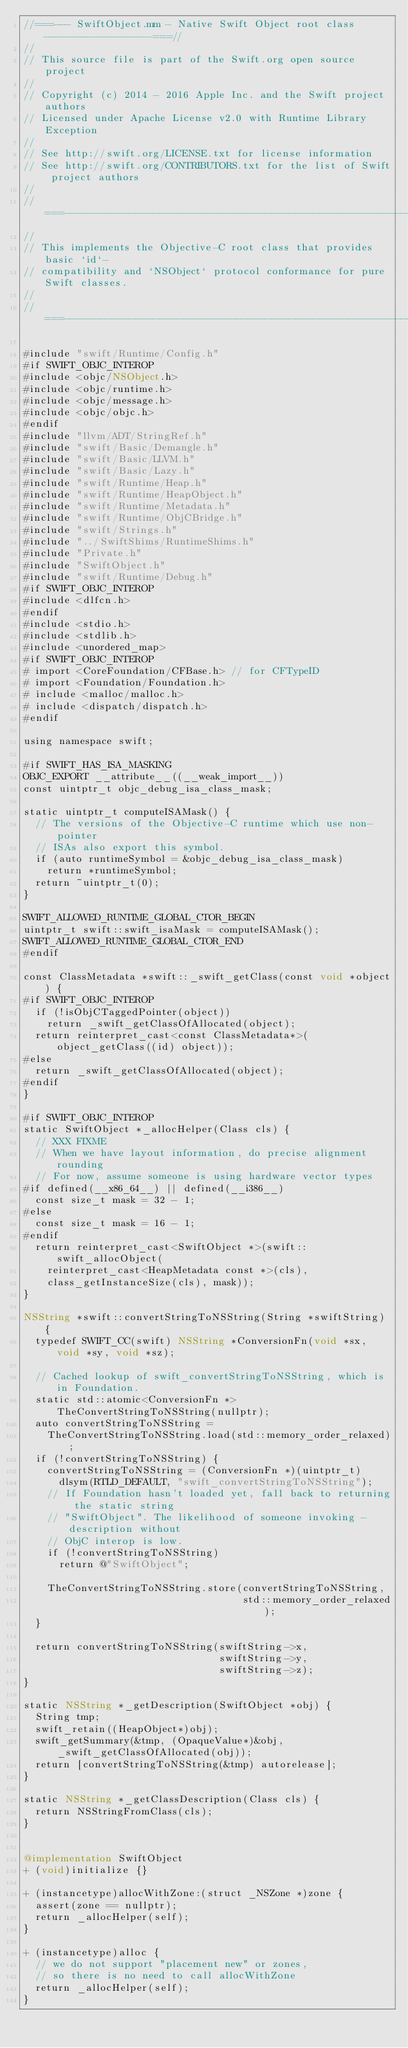Convert code to text. <code><loc_0><loc_0><loc_500><loc_500><_ObjectiveC_>//===--- SwiftObject.mm - Native Swift Object root class ------------------===//
//
// This source file is part of the Swift.org open source project
//
// Copyright (c) 2014 - 2016 Apple Inc. and the Swift project authors
// Licensed under Apache License v2.0 with Runtime Library Exception
//
// See http://swift.org/LICENSE.txt for license information
// See http://swift.org/CONTRIBUTORS.txt for the list of Swift project authors
//
//===----------------------------------------------------------------------===//
//
// This implements the Objective-C root class that provides basic `id`-
// compatibility and `NSObject` protocol conformance for pure Swift classes.
//
//===----------------------------------------------------------------------===//

#include "swift/Runtime/Config.h"
#if SWIFT_OBJC_INTEROP
#include <objc/NSObject.h>
#include <objc/runtime.h>
#include <objc/message.h>
#include <objc/objc.h>
#endif
#include "llvm/ADT/StringRef.h"
#include "swift/Basic/Demangle.h"
#include "swift/Basic/LLVM.h"
#include "swift/Basic/Lazy.h"
#include "swift/Runtime/Heap.h"
#include "swift/Runtime/HeapObject.h"
#include "swift/Runtime/Metadata.h"
#include "swift/Runtime/ObjCBridge.h"
#include "swift/Strings.h"
#include "../SwiftShims/RuntimeShims.h"
#include "Private.h"
#include "SwiftObject.h"
#include "swift/Runtime/Debug.h"
#if SWIFT_OBJC_INTEROP
#include <dlfcn.h>
#endif
#include <stdio.h>
#include <stdlib.h>
#include <unordered_map>
#if SWIFT_OBJC_INTEROP
# import <CoreFoundation/CFBase.h> // for CFTypeID
# import <Foundation/Foundation.h>
# include <malloc/malloc.h>
# include <dispatch/dispatch.h>
#endif

using namespace swift;

#if SWIFT_HAS_ISA_MASKING
OBJC_EXPORT __attribute__((__weak_import__))
const uintptr_t objc_debug_isa_class_mask;

static uintptr_t computeISAMask() {
  // The versions of the Objective-C runtime which use non-pointer
  // ISAs also export this symbol.
  if (auto runtimeSymbol = &objc_debug_isa_class_mask)
    return *runtimeSymbol;
  return ~uintptr_t(0);
}

SWIFT_ALLOWED_RUNTIME_GLOBAL_CTOR_BEGIN
uintptr_t swift::swift_isaMask = computeISAMask();
SWIFT_ALLOWED_RUNTIME_GLOBAL_CTOR_END
#endif

const ClassMetadata *swift::_swift_getClass(const void *object) {
#if SWIFT_OBJC_INTEROP
  if (!isObjCTaggedPointer(object))
    return _swift_getClassOfAllocated(object);
  return reinterpret_cast<const ClassMetadata*>(object_getClass((id) object));
#else
  return _swift_getClassOfAllocated(object);
#endif
}

#if SWIFT_OBJC_INTEROP
static SwiftObject *_allocHelper(Class cls) {
  // XXX FIXME
  // When we have layout information, do precise alignment rounding
  // For now, assume someone is using hardware vector types
#if defined(__x86_64__) || defined(__i386__)
  const size_t mask = 32 - 1;
#else
  const size_t mask = 16 - 1;
#endif
  return reinterpret_cast<SwiftObject *>(swift::swift_allocObject(
    reinterpret_cast<HeapMetadata const *>(cls),
    class_getInstanceSize(cls), mask));
}

NSString *swift::convertStringToNSString(String *swiftString) {
  typedef SWIFT_CC(swift) NSString *ConversionFn(void *sx, void *sy, void *sz);

  // Cached lookup of swift_convertStringToNSString, which is in Foundation.
  static std::atomic<ConversionFn *> TheConvertStringToNSString(nullptr);
  auto convertStringToNSString =
    TheConvertStringToNSString.load(std::memory_order_relaxed);
  if (!convertStringToNSString) {
    convertStringToNSString = (ConversionFn *)(uintptr_t)
      dlsym(RTLD_DEFAULT, "swift_convertStringToNSString");
    // If Foundation hasn't loaded yet, fall back to returning the static string
    // "SwiftObject". The likelihood of someone invoking -description without
    // ObjC interop is low.
    if (!convertStringToNSString)
      return @"SwiftObject";
    
    TheConvertStringToNSString.store(convertStringToNSString,
                                     std::memory_order_relaxed);
  }
  
  return convertStringToNSString(swiftString->x,
                                 swiftString->y,
                                 swiftString->z);
}

static NSString *_getDescription(SwiftObject *obj) {
  String tmp;
  swift_retain((HeapObject*)obj);
  swift_getSummary(&tmp, (OpaqueValue*)&obj, _swift_getClassOfAllocated(obj));
  return [convertStringToNSString(&tmp) autorelease];
}

static NSString *_getClassDescription(Class cls) {
  return NSStringFromClass(cls);
}


@implementation SwiftObject
+ (void)initialize {}

+ (instancetype)allocWithZone:(struct _NSZone *)zone {
  assert(zone == nullptr);
  return _allocHelper(self);
}

+ (instancetype)alloc {
  // we do not support "placement new" or zones,
  // so there is no need to call allocWithZone
  return _allocHelper(self);
}
</code> 